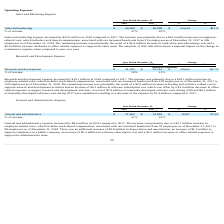According to Everbridge's financial document, What was the increase in the General and administrative in 2018? According to the financial document, $8.6 million. The relevant text states: "General and administrative expense increased by $8.6 million in 2018 compared to 2017. The increase was primarily due to a $3.7 million increase in employee-rela..." Also, What was the General and administrative in 2018 and 2017? The document shows two values: 31,462 and 22,895 (in thousands). From the document: "General and administrative $ 31,462 $ 22,895 $ 8,567 37.4% General and administrative $ 31,462 $ 22,895 $ 8,567 37.4%..." Also, What was the increase in depreciation and amortization from 2017 to 2018? According to the financial document, $2.8 million. The relevant text states: "mber 31, 2018. There was an additional increase of $2.8 million in depreciation and amortization, an increase of $1.5 million to support compliance as a public comp..." Also, can you calculate: What is the average General and administrative expense for 2017 and 2018? To answer this question, I need to perform calculations using the financial data. The calculation is: (31,462 + 22,895) / 2, which equals 27178.5 (in thousands). This is based on the information: "General and administrative $ 31,462 $ 22,895 $ 8,567 37.4% General and administrative $ 31,462 $ 22,895 $ 8,567 37.4%..." The key data points involved are: 22,895, 31,462. Additionally, In which year was General and administrative expense less than 40,000 thousands? The document shows two values: 2018 and 2017. Locate and analyze general and administrative in row 4. From the document: "2018 2017 $ % 2018 2017 $ %..." Also, can you calculate: What is the change in the gross margin between 2017 and 2018? Based on the calculation: 21 - 22, the result is -1 (in thousands). This is based on the information: "% of revenue 21% 22% % of revenue 21% 22%..." The key data points involved are: 21, 22. 